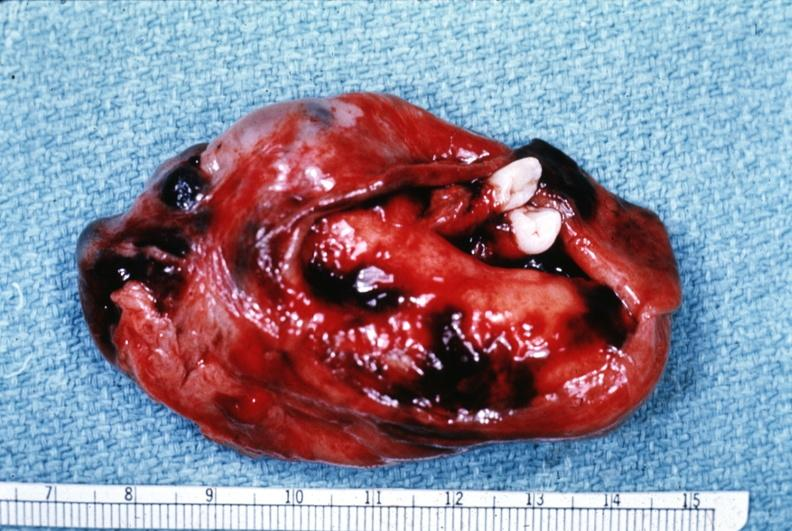s ovary present?
Answer the question using a single word or phrase. Yes 